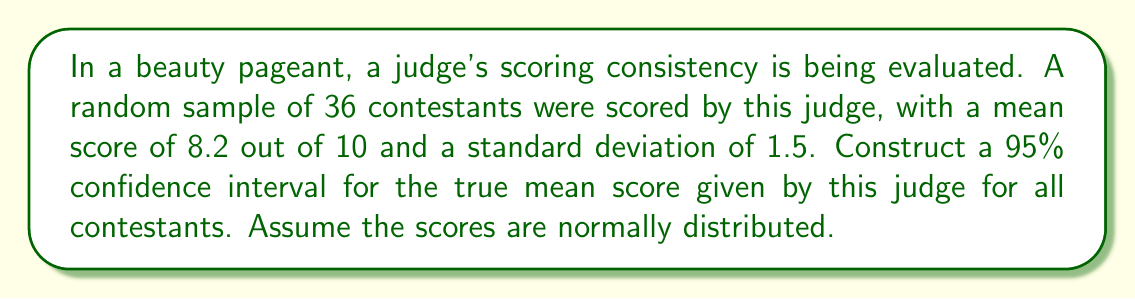Can you answer this question? To construct a 95% confidence interval, we'll follow these steps:

1) The formula for a confidence interval is:

   $$ \bar{x} \pm t_{\alpha/2} \cdot \frac{s}{\sqrt{n}} $$

   Where:
   $\bar{x}$ is the sample mean
   $t_{\alpha/2}$ is the t-value for a 95% confidence level
   $s$ is the sample standard deviation
   $n$ is the sample size

2) We know:
   $\bar{x} = 8.2$
   $s = 1.5$
   $n = 36$
   Confidence level = 95%, so $\alpha = 0.05$

3) For a 95% confidence interval with 35 degrees of freedom (n-1), the t-value is approximately 2.030 (from t-distribution table).

4) Now, let's substitute these values into our formula:

   $$ 8.2 \pm 2.030 \cdot \frac{1.5}{\sqrt{36}} $$

5) Simplify:
   $$ 8.2 \pm 2.030 \cdot \frac{1.5}{6} $$
   $$ 8.2 \pm 2.030 \cdot 0.25 $$
   $$ 8.2 \pm 0.5075 $$

6) Calculate the interval:
   $$ (8.2 - 0.5075, 8.2 + 0.5075) $$
   $$ (7.6925, 8.7075) $$

Therefore, we can be 95% confident that the true mean score for all contestants lies between 7.6925 and 8.7075.
Answer: (7.6925, 8.7075) 